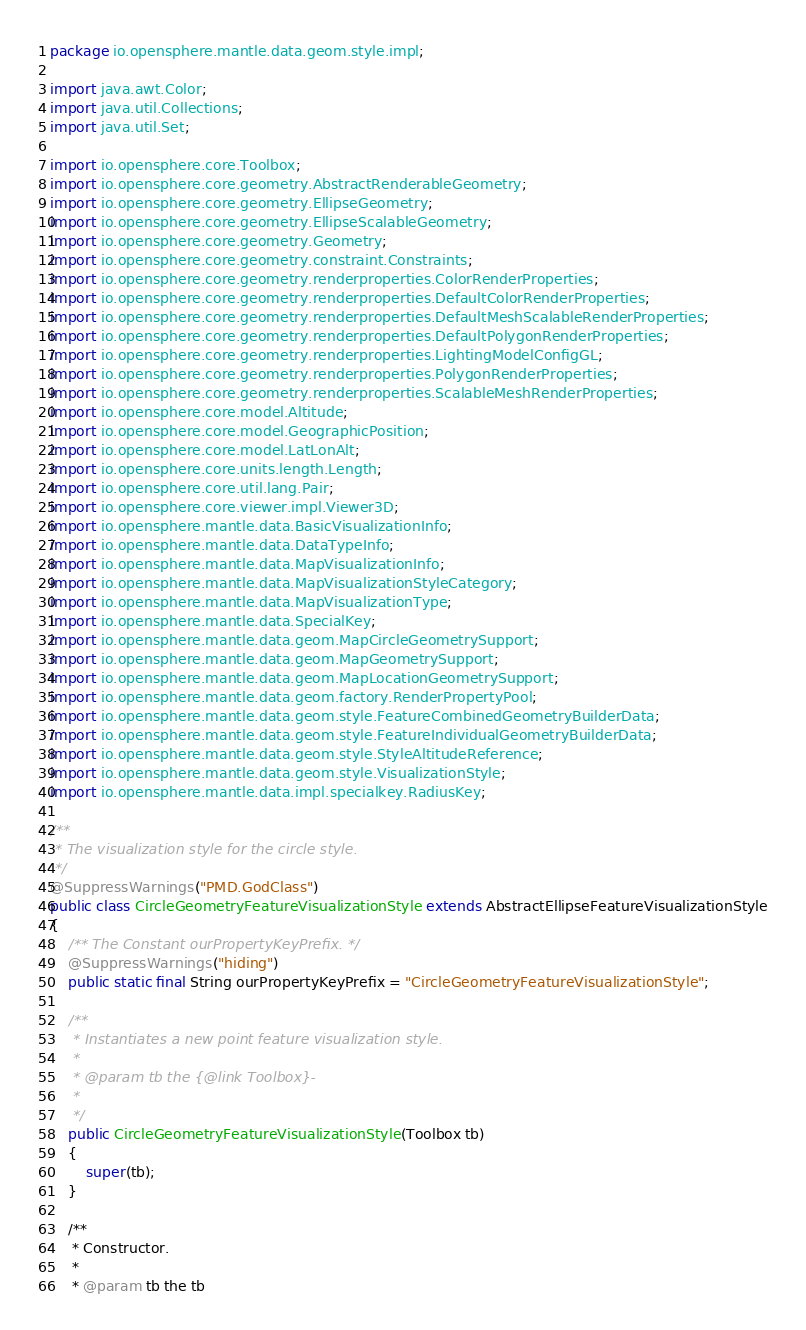<code> <loc_0><loc_0><loc_500><loc_500><_Java_>package io.opensphere.mantle.data.geom.style.impl;

import java.awt.Color;
import java.util.Collections;
import java.util.Set;

import io.opensphere.core.Toolbox;
import io.opensphere.core.geometry.AbstractRenderableGeometry;
import io.opensphere.core.geometry.EllipseGeometry;
import io.opensphere.core.geometry.EllipseScalableGeometry;
import io.opensphere.core.geometry.Geometry;
import io.opensphere.core.geometry.constraint.Constraints;
import io.opensphere.core.geometry.renderproperties.ColorRenderProperties;
import io.opensphere.core.geometry.renderproperties.DefaultColorRenderProperties;
import io.opensphere.core.geometry.renderproperties.DefaultMeshScalableRenderProperties;
import io.opensphere.core.geometry.renderproperties.DefaultPolygonRenderProperties;
import io.opensphere.core.geometry.renderproperties.LightingModelConfigGL;
import io.opensphere.core.geometry.renderproperties.PolygonRenderProperties;
import io.opensphere.core.geometry.renderproperties.ScalableMeshRenderProperties;
import io.opensphere.core.model.Altitude;
import io.opensphere.core.model.GeographicPosition;
import io.opensphere.core.model.LatLonAlt;
import io.opensphere.core.units.length.Length;
import io.opensphere.core.util.lang.Pair;
import io.opensphere.core.viewer.impl.Viewer3D;
import io.opensphere.mantle.data.BasicVisualizationInfo;
import io.opensphere.mantle.data.DataTypeInfo;
import io.opensphere.mantle.data.MapVisualizationInfo;
import io.opensphere.mantle.data.MapVisualizationStyleCategory;
import io.opensphere.mantle.data.MapVisualizationType;
import io.opensphere.mantle.data.SpecialKey;
import io.opensphere.mantle.data.geom.MapCircleGeometrySupport;
import io.opensphere.mantle.data.geom.MapGeometrySupport;
import io.opensphere.mantle.data.geom.MapLocationGeometrySupport;
import io.opensphere.mantle.data.geom.factory.RenderPropertyPool;
import io.opensphere.mantle.data.geom.style.FeatureCombinedGeometryBuilderData;
import io.opensphere.mantle.data.geom.style.FeatureIndividualGeometryBuilderData;
import io.opensphere.mantle.data.geom.style.StyleAltitudeReference;
import io.opensphere.mantle.data.geom.style.VisualizationStyle;
import io.opensphere.mantle.data.impl.specialkey.RadiusKey;

/**
 * The visualization style for the circle style.
 */
@SuppressWarnings("PMD.GodClass")
public class CircleGeometryFeatureVisualizationStyle extends AbstractEllipseFeatureVisualizationStyle
{
    /** The Constant ourPropertyKeyPrefix. */
    @SuppressWarnings("hiding")
    public static final String ourPropertyKeyPrefix = "CircleGeometryFeatureVisualizationStyle";

    /**
     * Instantiates a new point feature visualization style.
     *
     * @param tb the {@link Toolbox}-
     *
     */
    public CircleGeometryFeatureVisualizationStyle(Toolbox tb)
    {
        super(tb);
    }

    /**
     * Constructor.
     *
     * @param tb the tb</code> 